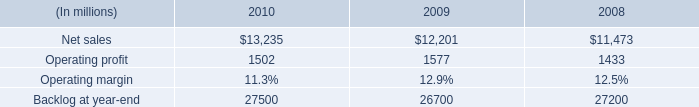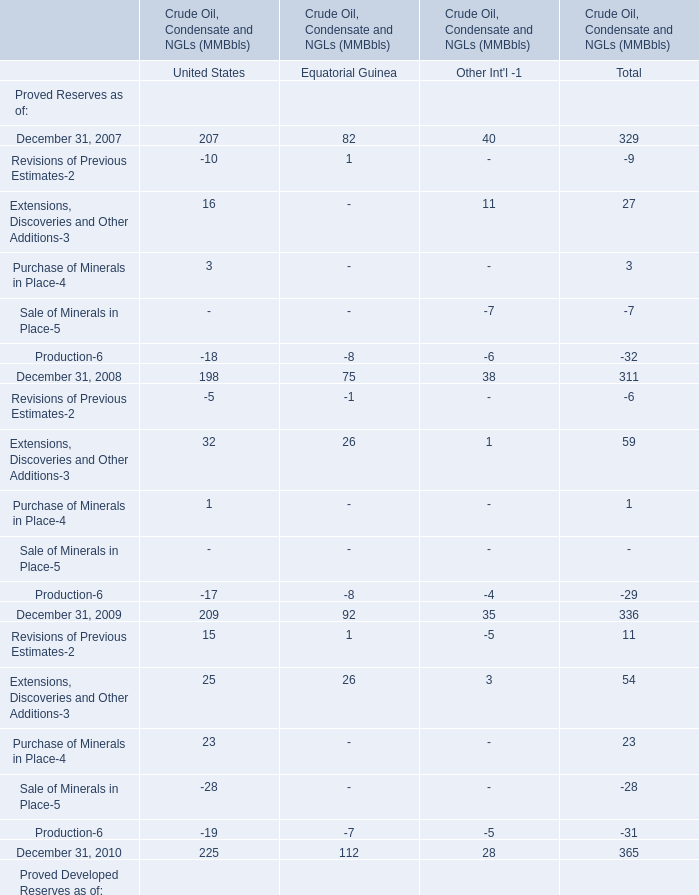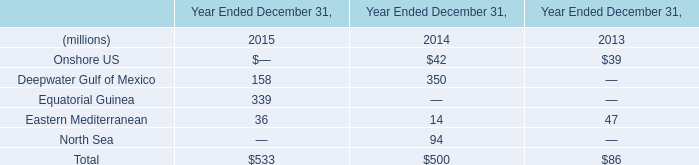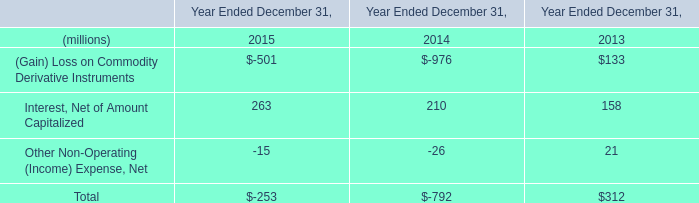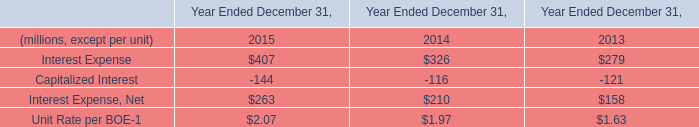what is the percentage change in operating income from 2009 to 2010? 
Computations: ((1502 - 1577) / 1577)
Answer: -0.04756. 